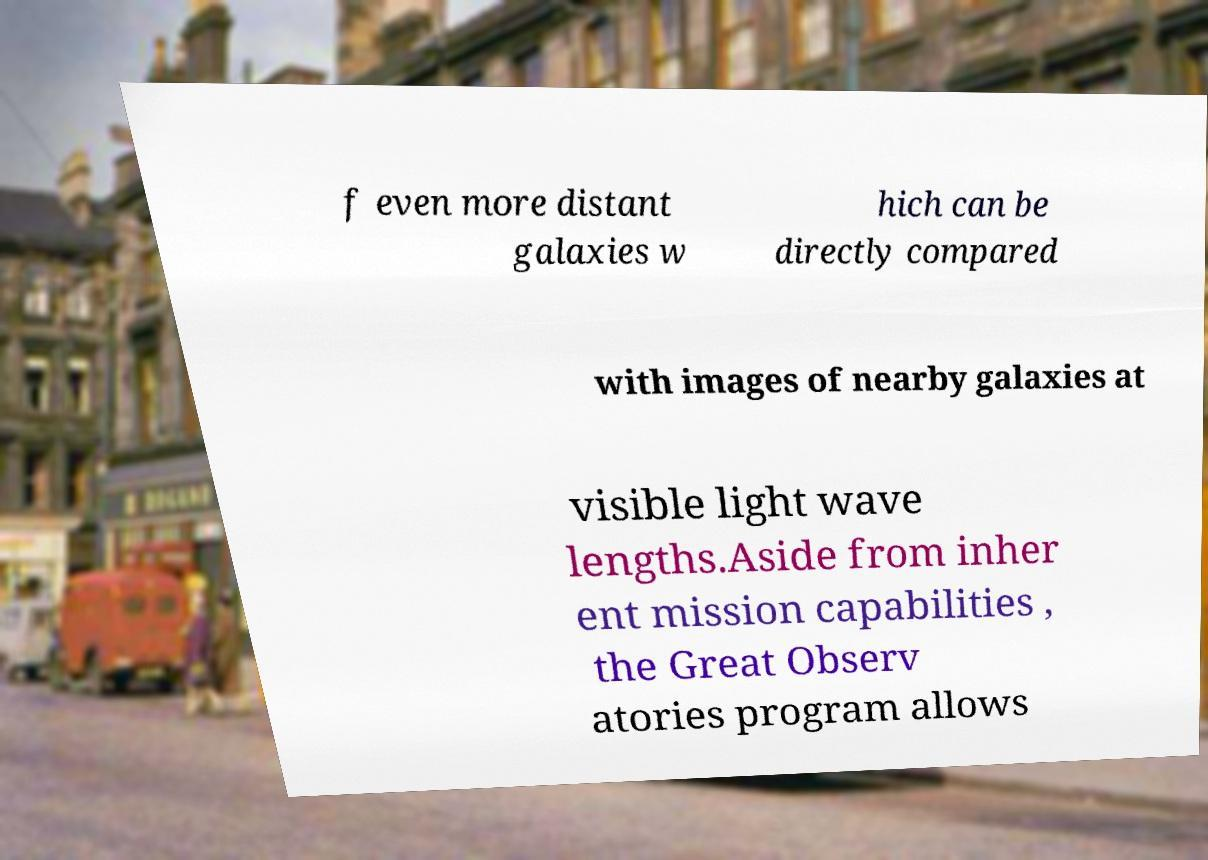For documentation purposes, I need the text within this image transcribed. Could you provide that? f even more distant galaxies w hich can be directly compared with images of nearby galaxies at visible light wave lengths.Aside from inher ent mission capabilities , the Great Observ atories program allows 